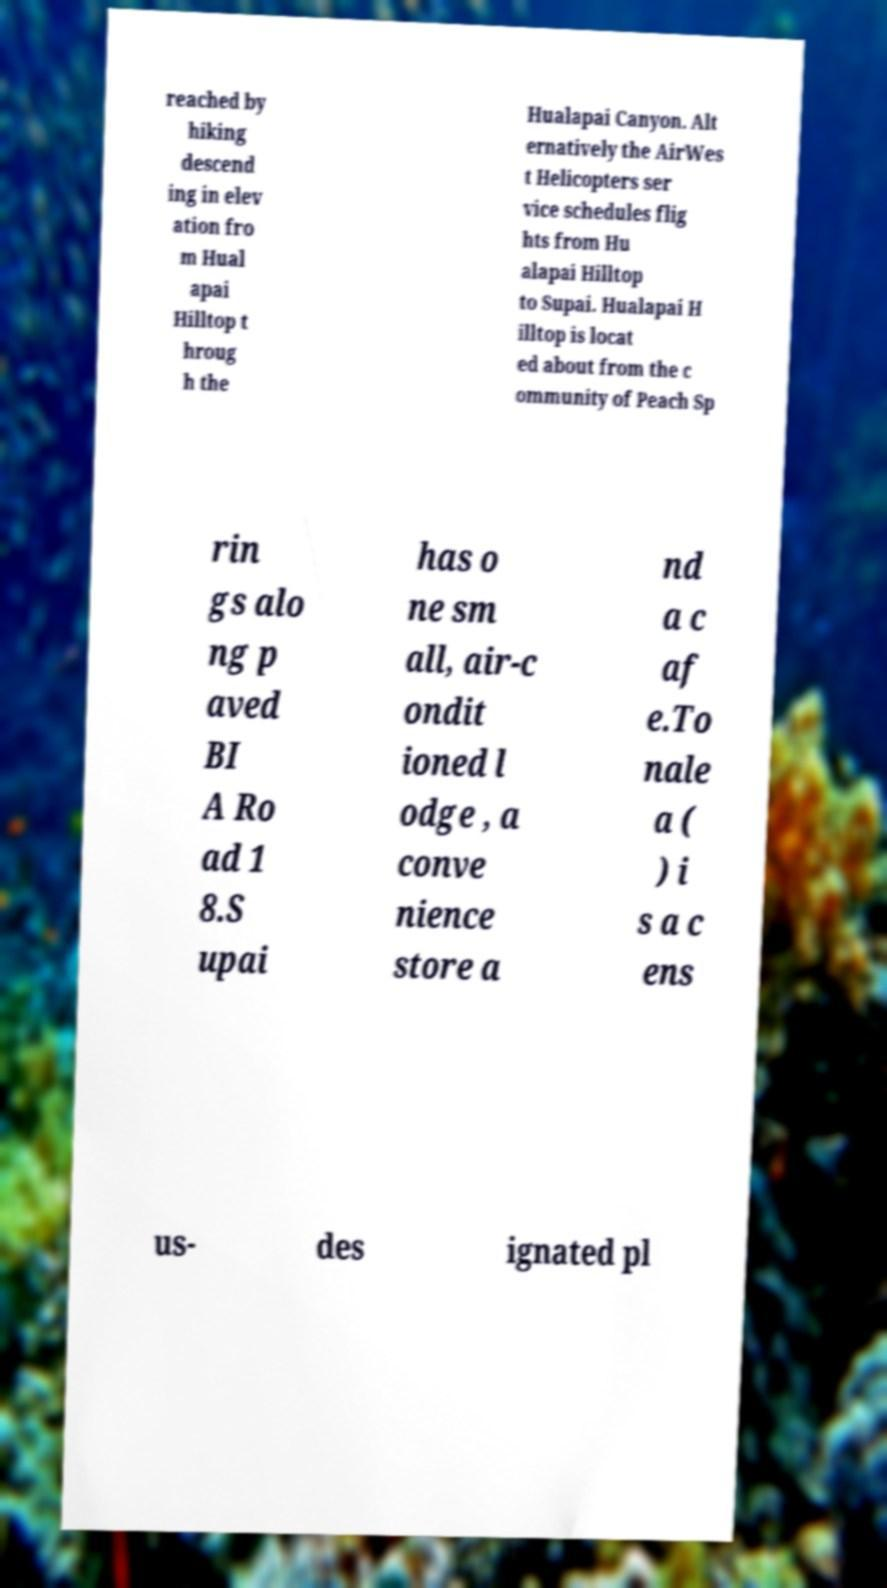Can you accurately transcribe the text from the provided image for me? reached by hiking descend ing in elev ation fro m Hual apai Hilltop t hroug h the Hualapai Canyon. Alt ernatively the AirWes t Helicopters ser vice schedules flig hts from Hu alapai Hilltop to Supai. Hualapai H illtop is locat ed about from the c ommunity of Peach Sp rin gs alo ng p aved BI A Ro ad 1 8.S upai has o ne sm all, air-c ondit ioned l odge , a conve nience store a nd a c af e.To nale a ( ) i s a c ens us- des ignated pl 